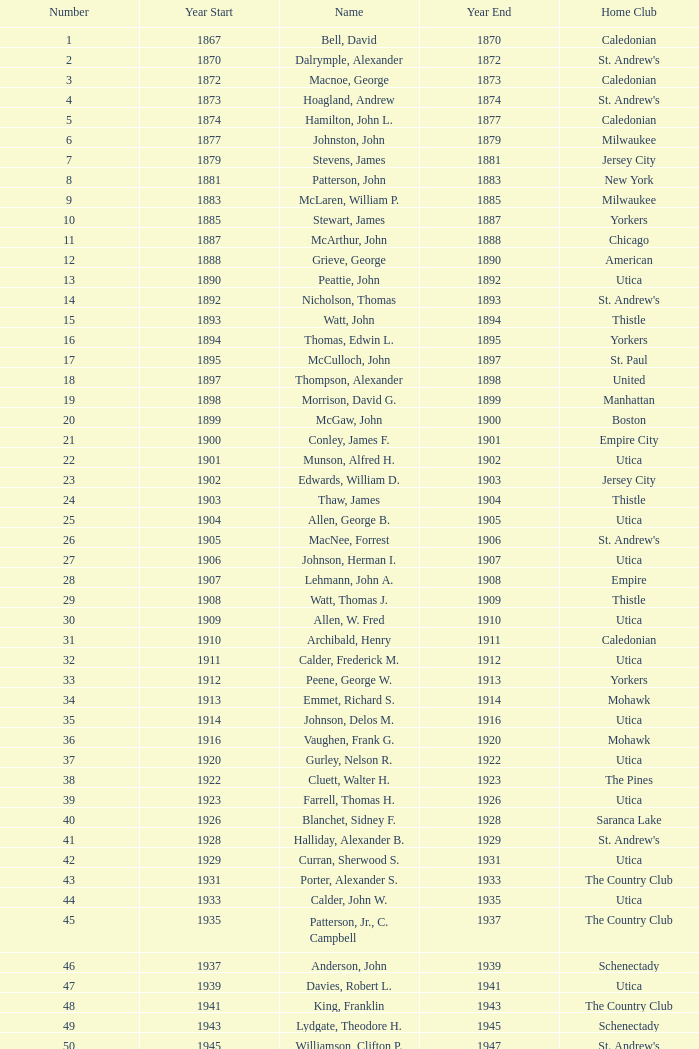Which Number has a Name of hill, lucius t.? 53.0. 